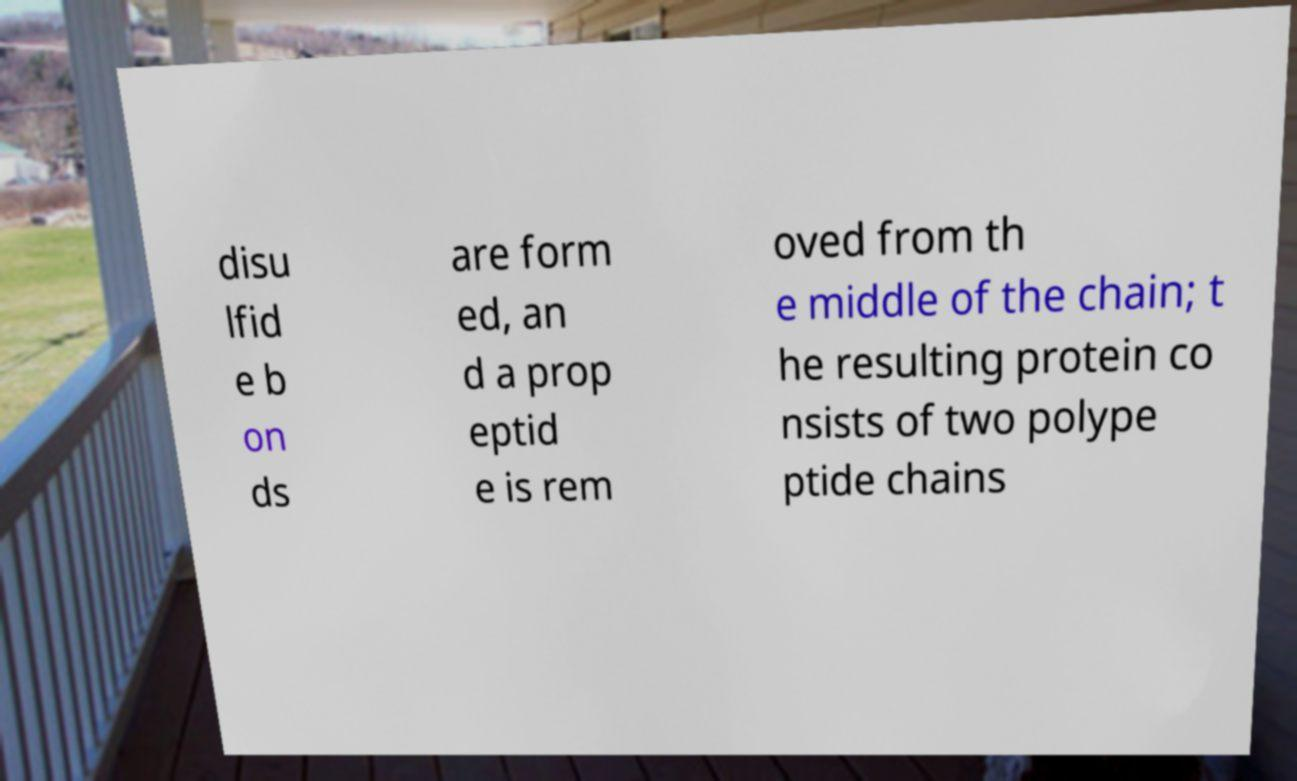There's text embedded in this image that I need extracted. Can you transcribe it verbatim? disu lfid e b on ds are form ed, an d a prop eptid e is rem oved from th e middle of the chain; t he resulting protein co nsists of two polype ptide chains 